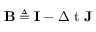<formula> <loc_0><loc_0><loc_500><loc_500>{ B } \triangle q { I } - { \Delta t } { J }</formula> 